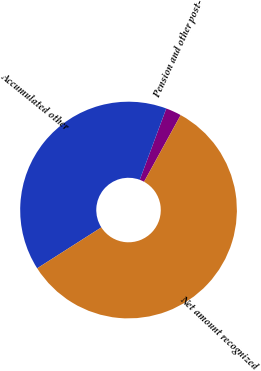<chart> <loc_0><loc_0><loc_500><loc_500><pie_chart><fcel>Pension and other post-<fcel>Accumulated other<fcel>Net amount recognized<nl><fcel>2.33%<fcel>39.7%<fcel>57.97%<nl></chart> 